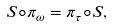<formula> <loc_0><loc_0><loc_500><loc_500>S \circ \pi _ { \omega } = \pi _ { \tau } \circ S ,</formula> 